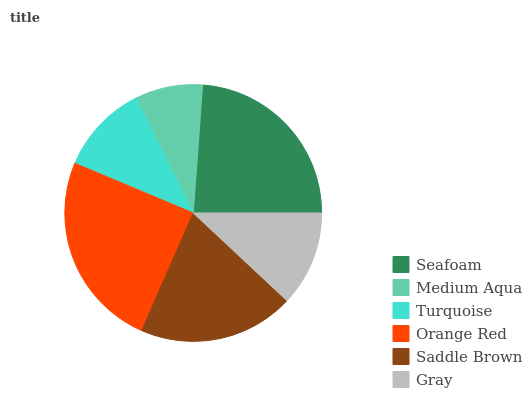Is Medium Aqua the minimum?
Answer yes or no. Yes. Is Orange Red the maximum?
Answer yes or no. Yes. Is Turquoise the minimum?
Answer yes or no. No. Is Turquoise the maximum?
Answer yes or no. No. Is Turquoise greater than Medium Aqua?
Answer yes or no. Yes. Is Medium Aqua less than Turquoise?
Answer yes or no. Yes. Is Medium Aqua greater than Turquoise?
Answer yes or no. No. Is Turquoise less than Medium Aqua?
Answer yes or no. No. Is Saddle Brown the high median?
Answer yes or no. Yes. Is Gray the low median?
Answer yes or no. Yes. Is Gray the high median?
Answer yes or no. No. Is Seafoam the low median?
Answer yes or no. No. 